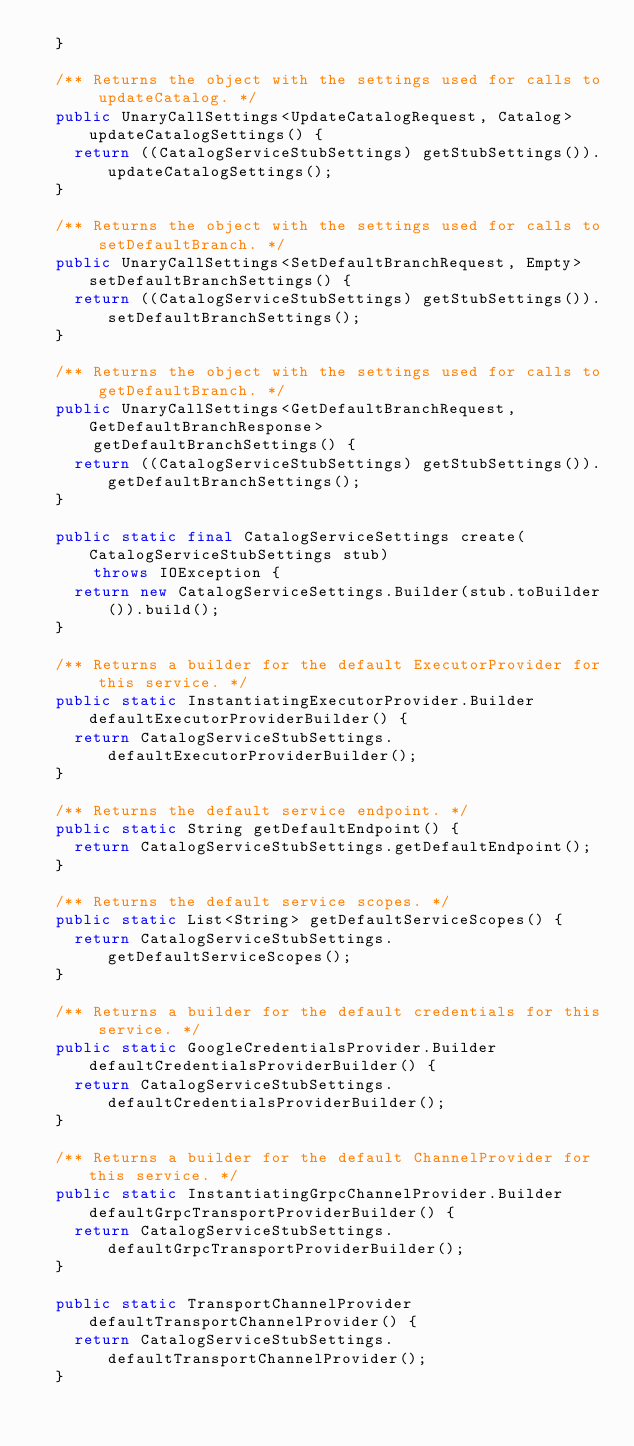<code> <loc_0><loc_0><loc_500><loc_500><_Java_>  }

  /** Returns the object with the settings used for calls to updateCatalog. */
  public UnaryCallSettings<UpdateCatalogRequest, Catalog> updateCatalogSettings() {
    return ((CatalogServiceStubSettings) getStubSettings()).updateCatalogSettings();
  }

  /** Returns the object with the settings used for calls to setDefaultBranch. */
  public UnaryCallSettings<SetDefaultBranchRequest, Empty> setDefaultBranchSettings() {
    return ((CatalogServiceStubSettings) getStubSettings()).setDefaultBranchSettings();
  }

  /** Returns the object with the settings used for calls to getDefaultBranch. */
  public UnaryCallSettings<GetDefaultBranchRequest, GetDefaultBranchResponse>
      getDefaultBranchSettings() {
    return ((CatalogServiceStubSettings) getStubSettings()).getDefaultBranchSettings();
  }

  public static final CatalogServiceSettings create(CatalogServiceStubSettings stub)
      throws IOException {
    return new CatalogServiceSettings.Builder(stub.toBuilder()).build();
  }

  /** Returns a builder for the default ExecutorProvider for this service. */
  public static InstantiatingExecutorProvider.Builder defaultExecutorProviderBuilder() {
    return CatalogServiceStubSettings.defaultExecutorProviderBuilder();
  }

  /** Returns the default service endpoint. */
  public static String getDefaultEndpoint() {
    return CatalogServiceStubSettings.getDefaultEndpoint();
  }

  /** Returns the default service scopes. */
  public static List<String> getDefaultServiceScopes() {
    return CatalogServiceStubSettings.getDefaultServiceScopes();
  }

  /** Returns a builder for the default credentials for this service. */
  public static GoogleCredentialsProvider.Builder defaultCredentialsProviderBuilder() {
    return CatalogServiceStubSettings.defaultCredentialsProviderBuilder();
  }

  /** Returns a builder for the default ChannelProvider for this service. */
  public static InstantiatingGrpcChannelProvider.Builder defaultGrpcTransportProviderBuilder() {
    return CatalogServiceStubSettings.defaultGrpcTransportProviderBuilder();
  }

  public static TransportChannelProvider defaultTransportChannelProvider() {
    return CatalogServiceStubSettings.defaultTransportChannelProvider();
  }
</code> 